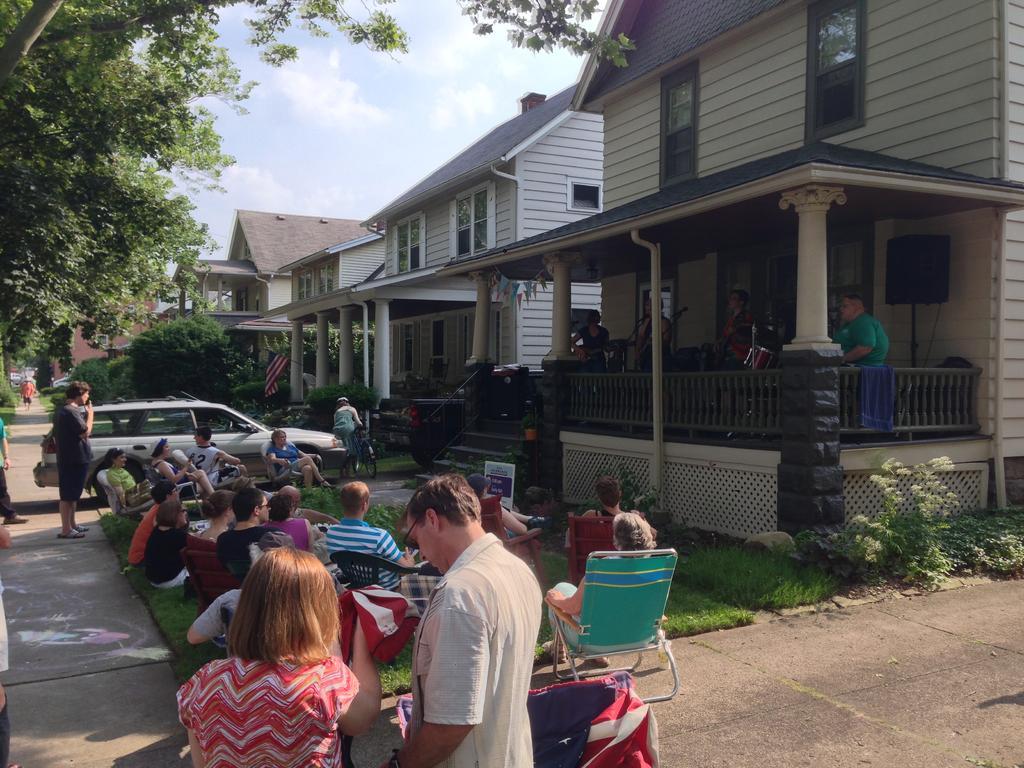Describe this image in one or two sentences. In this image we can see some houses with roof and windows and some people sitting under a roof. We can also see a group of people sitting on the grass. On the backside we can see a group of trees, a car parked beside, a man riding bicycle, some people standing and the sky which looks cloudy. 